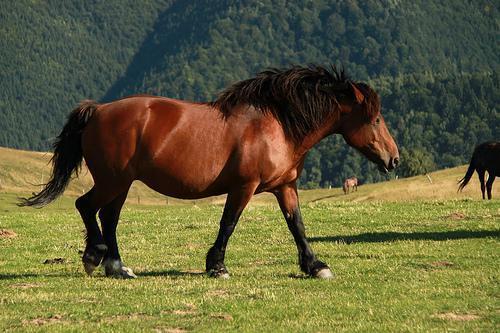How many horses can be seen?
Give a very brief answer. 3. 